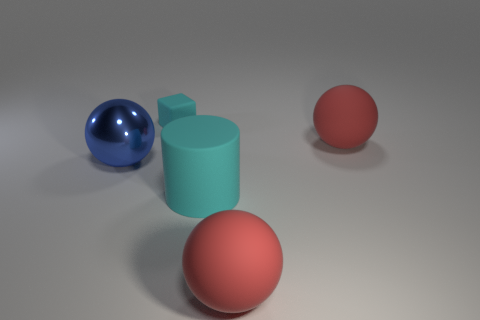Is there anything else that has the same color as the big metal object?
Your answer should be very brief. No. What color is the tiny thing?
Keep it short and to the point. Cyan. Is the color of the sphere behind the metallic ball the same as the matte ball that is in front of the big blue shiny ball?
Make the answer very short. Yes. What size is the cyan cube?
Your answer should be compact. Small. What size is the cyan matte object behind the large blue metal ball?
Make the answer very short. Small. There is a thing that is behind the large blue metal thing and on the left side of the large cyan object; what is its shape?
Your response must be concise. Cube. How many other things are the same shape as the big blue thing?
Your answer should be compact. 2. The metal ball that is the same size as the cyan rubber cylinder is what color?
Provide a short and direct response. Blue. How many objects are red matte things or big shiny objects?
Offer a very short reply. 3. There is a big cyan matte cylinder; are there any spheres behind it?
Your answer should be very brief. Yes. 